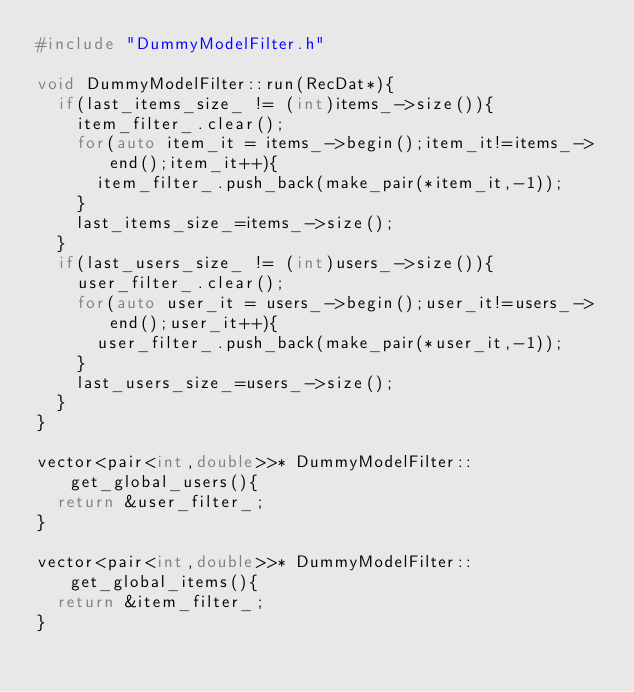Convert code to text. <code><loc_0><loc_0><loc_500><loc_500><_C++_>#include "DummyModelFilter.h"

void DummyModelFilter::run(RecDat*){
  if(last_items_size_ != (int)items_->size()){
    item_filter_.clear();
    for(auto item_it = items_->begin();item_it!=items_->end();item_it++){
      item_filter_.push_back(make_pair(*item_it,-1));
    }
    last_items_size_=items_->size();
  }
  if(last_users_size_ != (int)users_->size()){
    user_filter_.clear();
    for(auto user_it = users_->begin();user_it!=users_->end();user_it++){
      user_filter_.push_back(make_pair(*user_it,-1));
    }
    last_users_size_=users_->size();
  }
}

vector<pair<int,double>>* DummyModelFilter::get_global_users(){
  return &user_filter_;
}

vector<pair<int,double>>* DummyModelFilter::get_global_items(){
  return &item_filter_;
}

</code> 